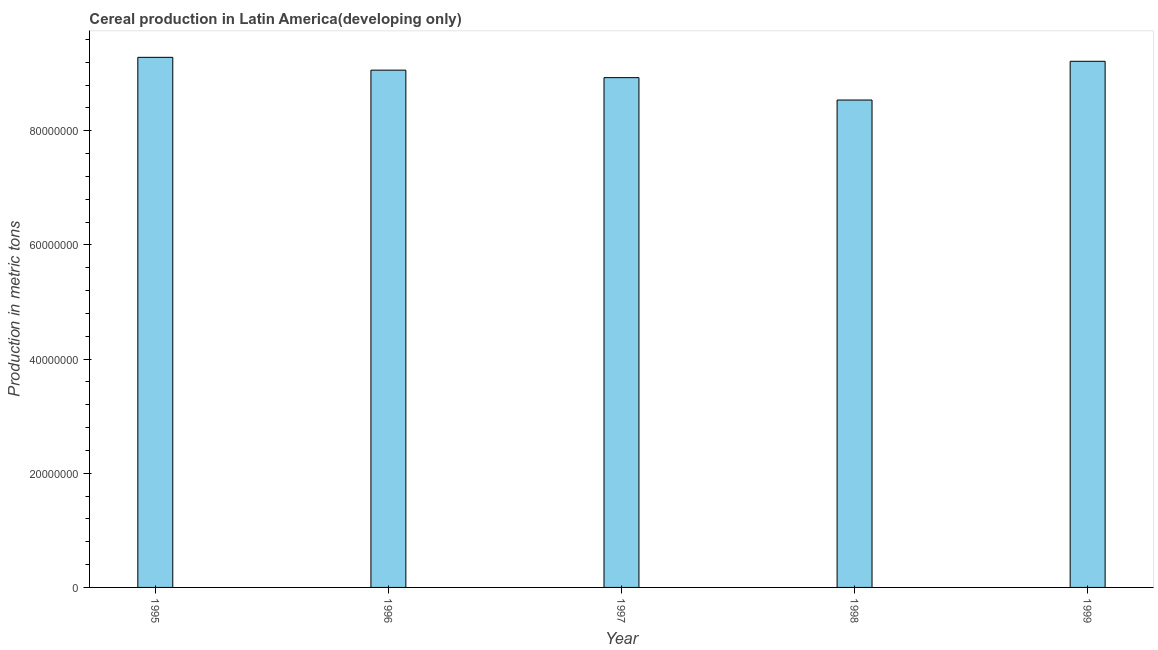What is the title of the graph?
Ensure brevity in your answer.  Cereal production in Latin America(developing only). What is the label or title of the Y-axis?
Ensure brevity in your answer.  Production in metric tons. What is the cereal production in 1999?
Your answer should be compact. 9.22e+07. Across all years, what is the maximum cereal production?
Keep it short and to the point. 9.29e+07. Across all years, what is the minimum cereal production?
Offer a terse response. 8.54e+07. What is the sum of the cereal production?
Give a very brief answer. 4.50e+08. What is the difference between the cereal production in 1995 and 1998?
Provide a short and direct response. 7.48e+06. What is the average cereal production per year?
Keep it short and to the point. 9.01e+07. What is the median cereal production?
Ensure brevity in your answer.  9.06e+07. In how many years, is the cereal production greater than 76000000 metric tons?
Give a very brief answer. 5. Do a majority of the years between 1998 and 1996 (inclusive) have cereal production greater than 12000000 metric tons?
Ensure brevity in your answer.  Yes. Is the cereal production in 1995 less than that in 1996?
Your response must be concise. No. Is the difference between the cereal production in 1997 and 1998 greater than the difference between any two years?
Offer a very short reply. No. What is the difference between the highest and the second highest cereal production?
Offer a very short reply. 6.94e+05. Is the sum of the cereal production in 1996 and 1997 greater than the maximum cereal production across all years?
Your answer should be compact. Yes. What is the difference between the highest and the lowest cereal production?
Make the answer very short. 7.48e+06. How many years are there in the graph?
Keep it short and to the point. 5. What is the Production in metric tons of 1995?
Your answer should be very brief. 9.29e+07. What is the Production in metric tons of 1996?
Offer a very short reply. 9.06e+07. What is the Production in metric tons in 1997?
Ensure brevity in your answer.  8.93e+07. What is the Production in metric tons in 1998?
Provide a succinct answer. 8.54e+07. What is the Production in metric tons of 1999?
Your answer should be compact. 9.22e+07. What is the difference between the Production in metric tons in 1995 and 1996?
Offer a terse response. 2.25e+06. What is the difference between the Production in metric tons in 1995 and 1997?
Keep it short and to the point. 3.56e+06. What is the difference between the Production in metric tons in 1995 and 1998?
Give a very brief answer. 7.48e+06. What is the difference between the Production in metric tons in 1995 and 1999?
Provide a succinct answer. 6.94e+05. What is the difference between the Production in metric tons in 1996 and 1997?
Your answer should be very brief. 1.31e+06. What is the difference between the Production in metric tons in 1996 and 1998?
Keep it short and to the point. 5.23e+06. What is the difference between the Production in metric tons in 1996 and 1999?
Give a very brief answer. -1.55e+06. What is the difference between the Production in metric tons in 1997 and 1998?
Offer a very short reply. 3.92e+06. What is the difference between the Production in metric tons in 1997 and 1999?
Make the answer very short. -2.87e+06. What is the difference between the Production in metric tons in 1998 and 1999?
Provide a short and direct response. -6.79e+06. What is the ratio of the Production in metric tons in 1995 to that in 1997?
Provide a succinct answer. 1.04. What is the ratio of the Production in metric tons in 1995 to that in 1998?
Ensure brevity in your answer.  1.09. What is the ratio of the Production in metric tons in 1995 to that in 1999?
Give a very brief answer. 1.01. What is the ratio of the Production in metric tons in 1996 to that in 1998?
Provide a succinct answer. 1.06. What is the ratio of the Production in metric tons in 1997 to that in 1998?
Offer a terse response. 1.05. What is the ratio of the Production in metric tons in 1997 to that in 1999?
Offer a very short reply. 0.97. What is the ratio of the Production in metric tons in 1998 to that in 1999?
Offer a terse response. 0.93. 